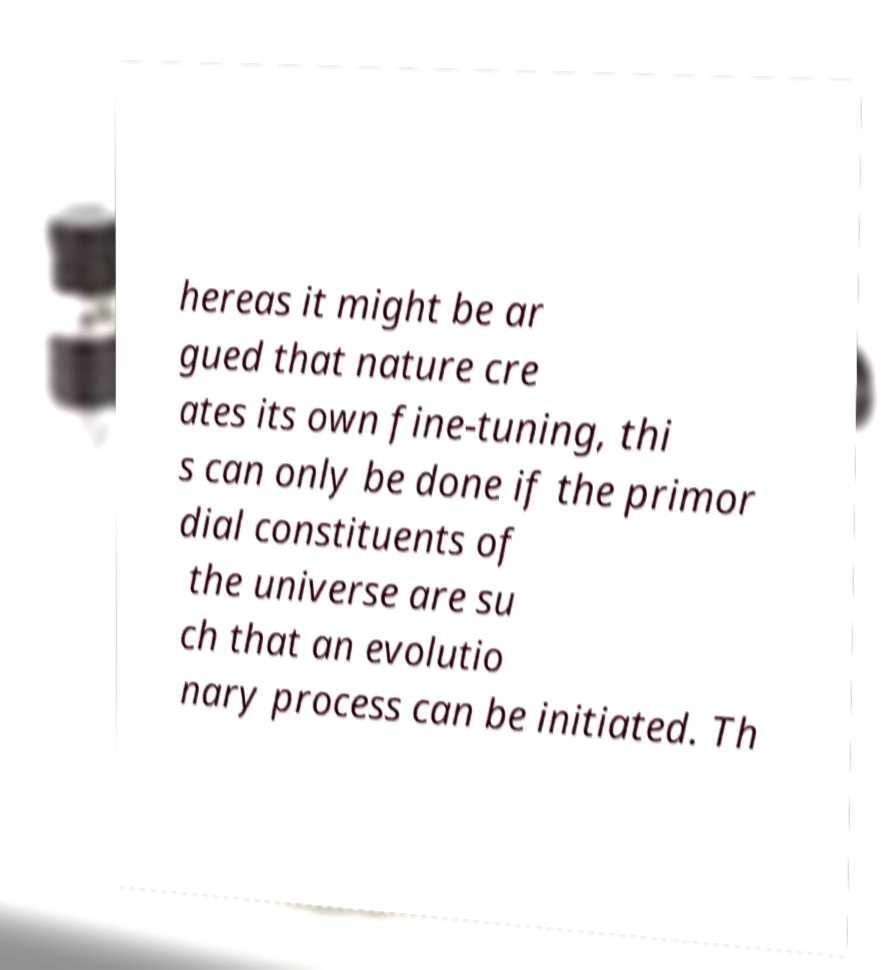For documentation purposes, I need the text within this image transcribed. Could you provide that? hereas it might be ar gued that nature cre ates its own fine-tuning, thi s can only be done if the primor dial constituents of the universe are su ch that an evolutio nary process can be initiated. Th 